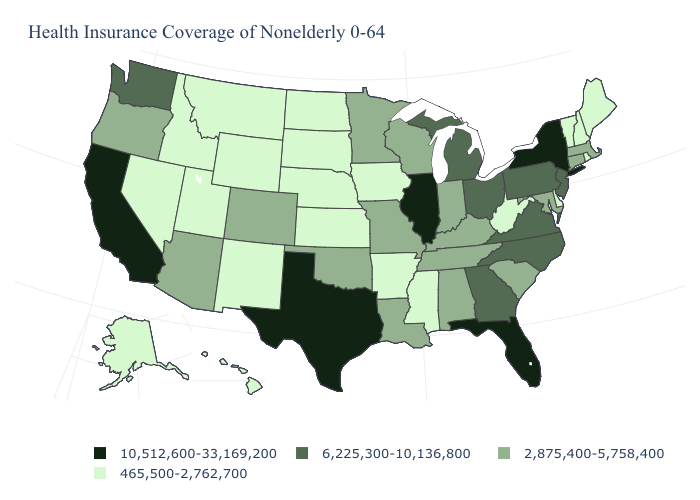What is the value of Oregon?
Answer briefly. 2,875,400-5,758,400. How many symbols are there in the legend?
Concise answer only. 4. Name the states that have a value in the range 465,500-2,762,700?
Short answer required. Alaska, Arkansas, Delaware, Hawaii, Idaho, Iowa, Kansas, Maine, Mississippi, Montana, Nebraska, Nevada, New Hampshire, New Mexico, North Dakota, Rhode Island, South Dakota, Utah, Vermont, West Virginia, Wyoming. Which states have the lowest value in the USA?
Concise answer only. Alaska, Arkansas, Delaware, Hawaii, Idaho, Iowa, Kansas, Maine, Mississippi, Montana, Nebraska, Nevada, New Hampshire, New Mexico, North Dakota, Rhode Island, South Dakota, Utah, Vermont, West Virginia, Wyoming. Which states hav the highest value in the Northeast?
Short answer required. New York. Which states hav the highest value in the South?
Write a very short answer. Florida, Texas. What is the value of Kentucky?
Give a very brief answer. 2,875,400-5,758,400. What is the value of Connecticut?
Write a very short answer. 2,875,400-5,758,400. Name the states that have a value in the range 2,875,400-5,758,400?
Give a very brief answer. Alabama, Arizona, Colorado, Connecticut, Indiana, Kentucky, Louisiana, Maryland, Massachusetts, Minnesota, Missouri, Oklahoma, Oregon, South Carolina, Tennessee, Wisconsin. Does the map have missing data?
Keep it brief. No. What is the lowest value in the USA?
Keep it brief. 465,500-2,762,700. What is the highest value in the West ?
Write a very short answer. 10,512,600-33,169,200. Which states hav the highest value in the South?
Answer briefly. Florida, Texas. Name the states that have a value in the range 10,512,600-33,169,200?
Keep it brief. California, Florida, Illinois, New York, Texas. Name the states that have a value in the range 6,225,300-10,136,800?
Keep it brief. Georgia, Michigan, New Jersey, North Carolina, Ohio, Pennsylvania, Virginia, Washington. 